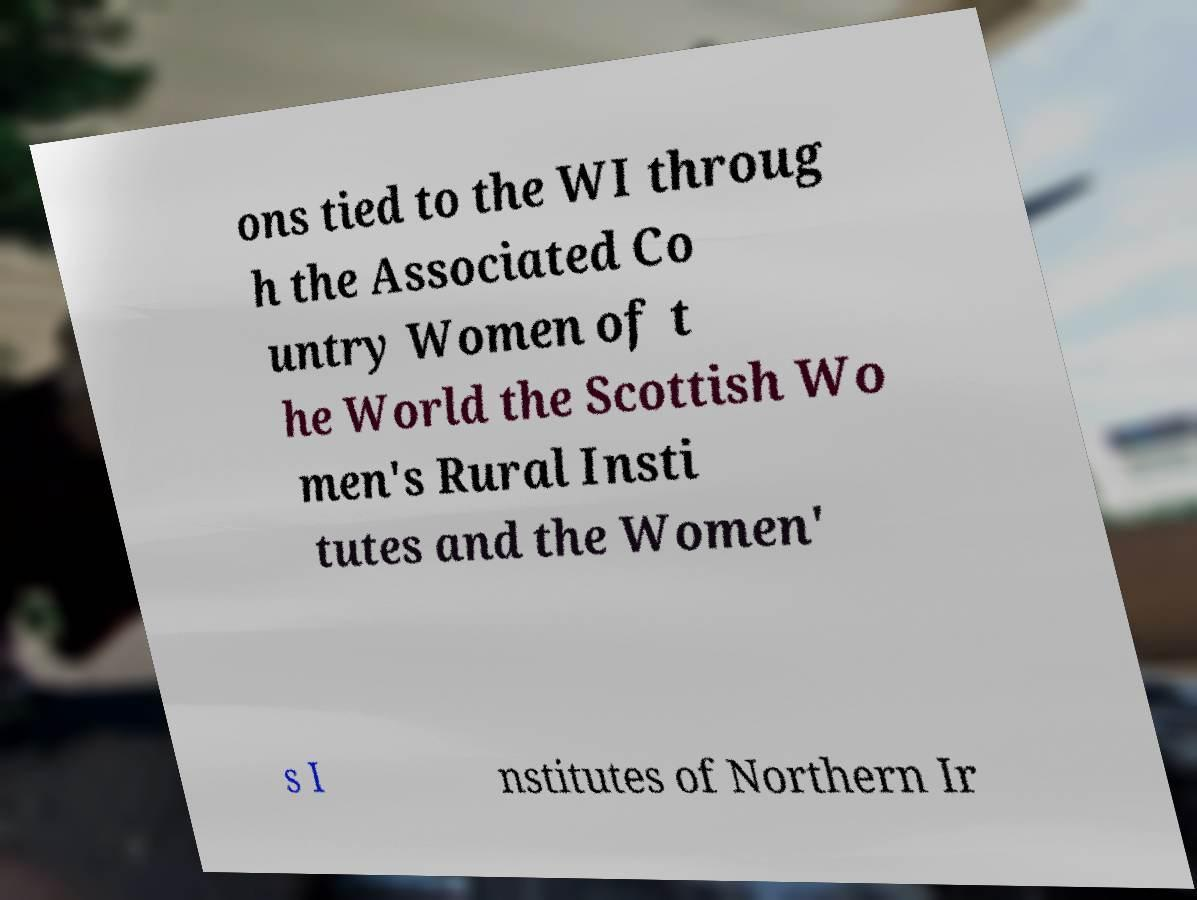Could you assist in decoding the text presented in this image and type it out clearly? ons tied to the WI throug h the Associated Co untry Women of t he World the Scottish Wo men's Rural Insti tutes and the Women' s I nstitutes of Northern Ir 